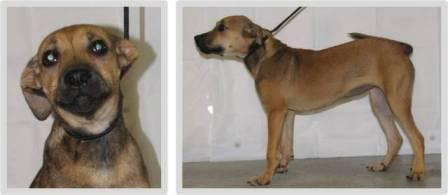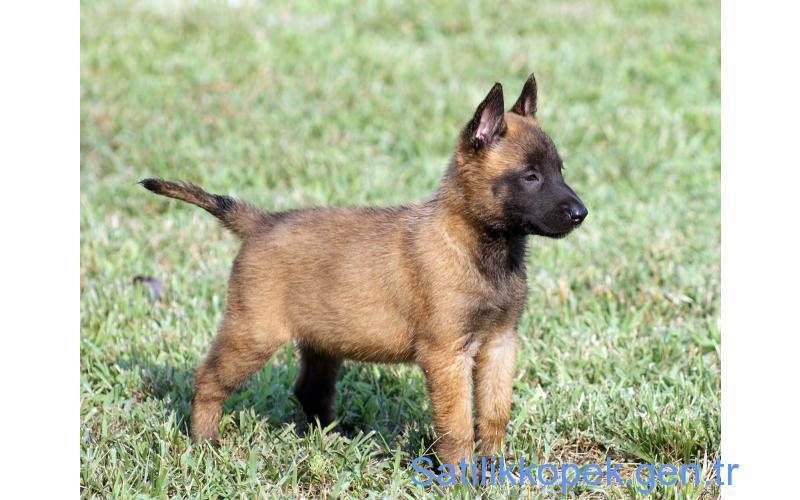The first image is the image on the left, the second image is the image on the right. Analyze the images presented: Is the assertion "The left photo shows a dog on top of a rock." valid? Answer yes or no. No. The first image is the image on the left, the second image is the image on the right. Analyze the images presented: Is the assertion "There are two dogs shown." valid? Answer yes or no. No. 